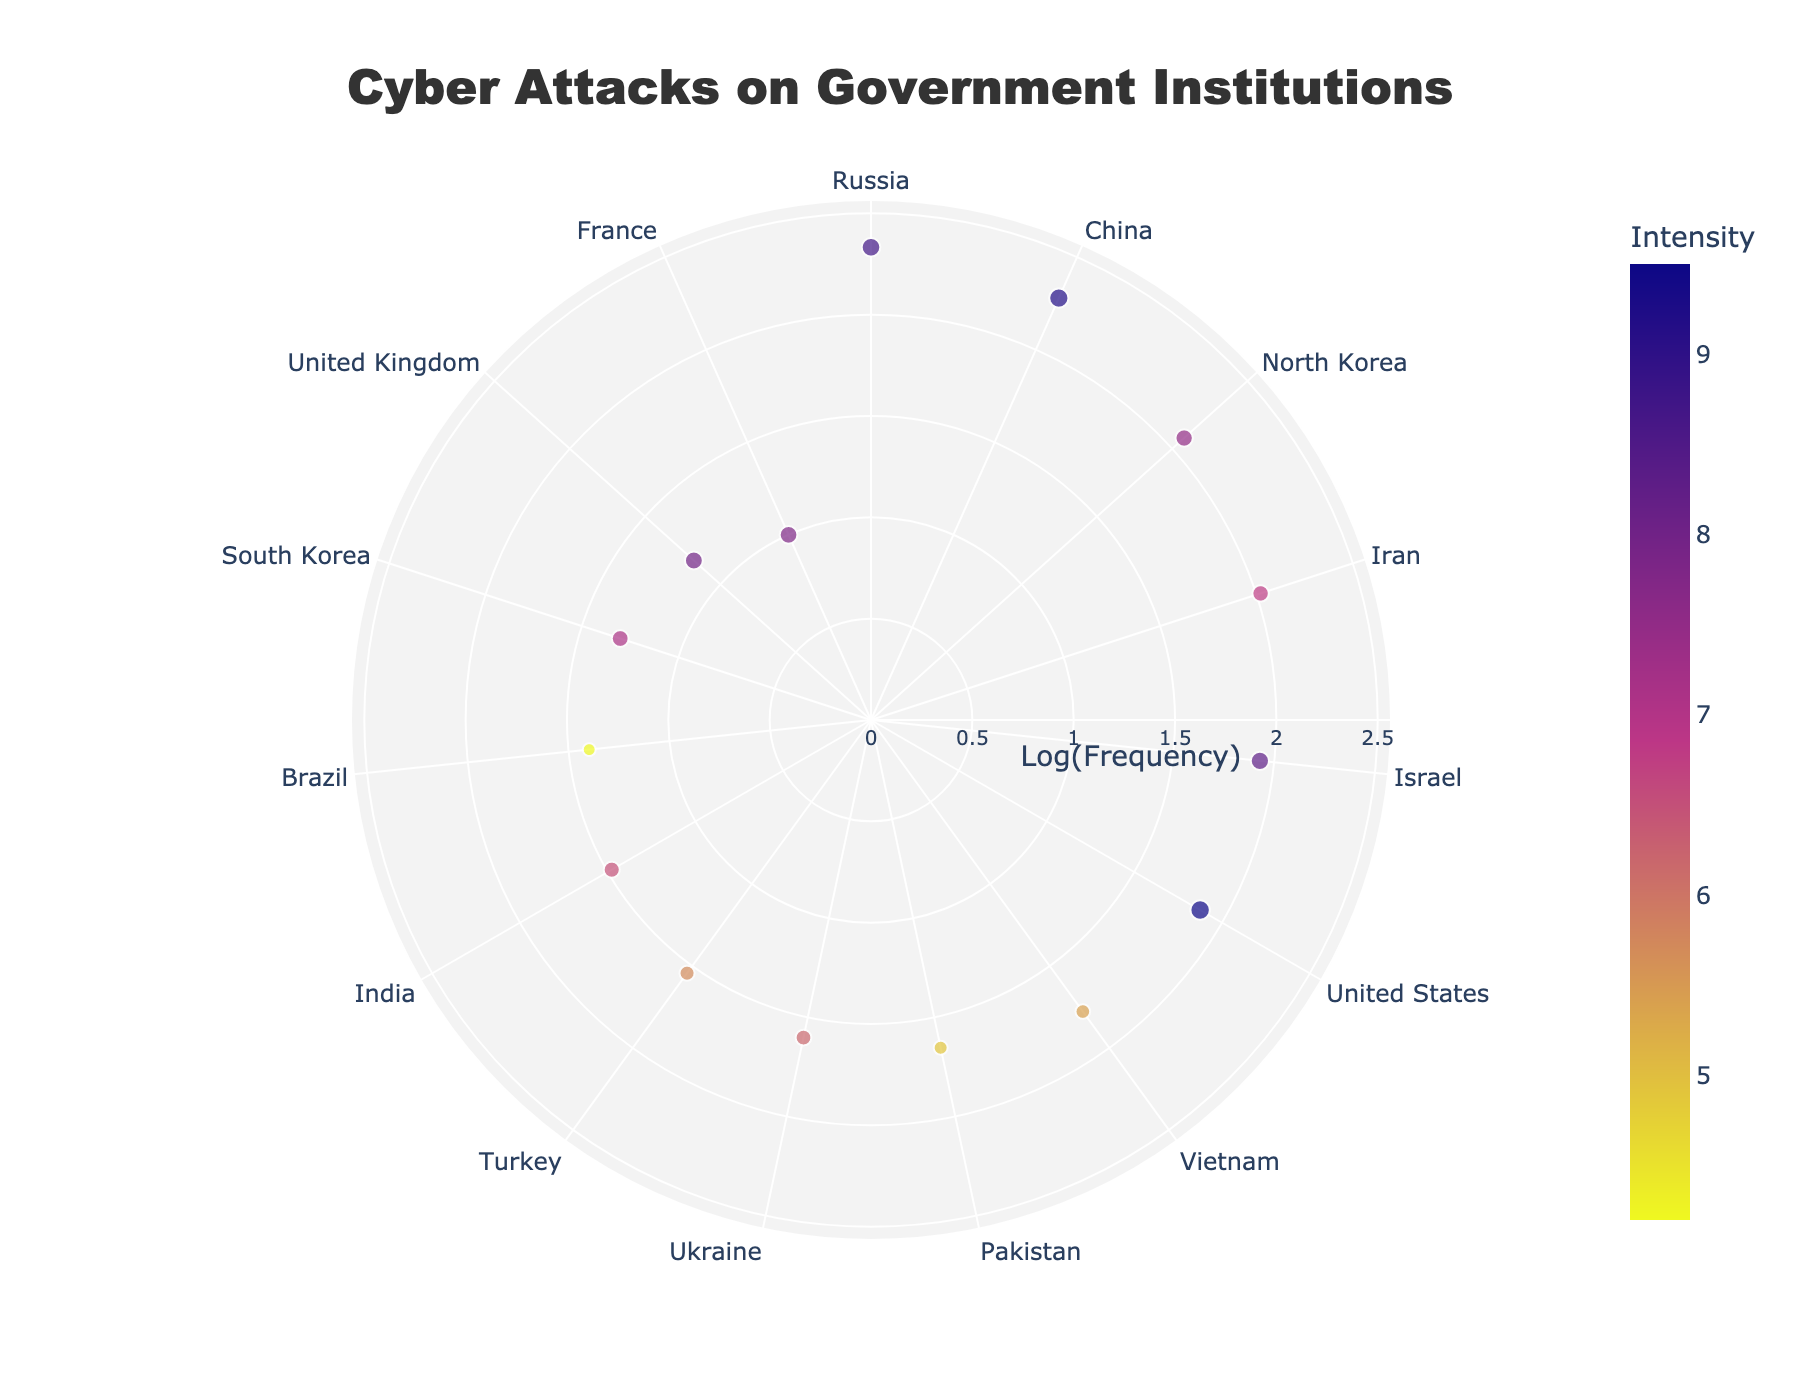What is the title of the figure? The title is located at the top of the figure and clearly states the subject of the plot.
Answer: Cyber Attacks on Government Institutions Which country has the highest frequency of cyber attacks? The country with the largest radial distance represents the highest frequency. "Russia" is at the maximum radial point.
Answer: Russia What is the color range representing the intensity of cyber attacks? The color scale on the figure shows a gradient from one color to another representing different intensities.
Answer: A gradient from dark purple to light yellow Which country has the highest intensity of cyber attacks? The marker corresponding to the highest value on the color scale (the brightest marker) indicates the country with the highest intensity.
Answer: United States How does the frequency of cyber attacks from China compare to North Korea? Compare the radial distances of the markers for China and North Korea. China has a larger radial distance, indicating a higher frequency.
Answer: China has higher frequency What is the approximate size of the marker representing Israel, and what does it signify about the intensity of the attacks? The size of the markers is proportional to the intensity of the attacks. Israel's marker is fairly large, signifying a high intensity close to 8.3.
Answer: Large marker, signifying high intensity Which country falls at the minimum frequency and intensity values according to the plot? Find the country at the smallest radial distance with the smallest marker size. "France" appears to have the lowest values based on visual inspection.
Answer: France How does the frequency of attacks by Iran compare to Turkey? Compare the radial distances of the markers for Iran and Turkey. Iran has a higher radial distance than Turkey, indicating a higher frequency.
Answer: Iran has higher frequency What is the angular position or rotation setting used for the plot? The angular axis rotation is stated in the configuration details provided in the explanation text. Rotation is set at 90 degrees, clockwise direction.
Answer: 90 degrees, clockwise What countries have a higher intensity than South Korea but a lower frequency than Russia? Compare the positions and intensities of countries between South Korea's marker size and intensity range, and Russia's radial position. Only China and the United States fit these criteria.
Answer: United States and China 